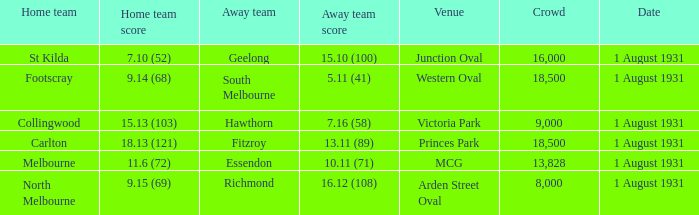Would you be able to parse every entry in this table? {'header': ['Home team', 'Home team score', 'Away team', 'Away team score', 'Venue', 'Crowd', 'Date'], 'rows': [['St Kilda', '7.10 (52)', 'Geelong', '15.10 (100)', 'Junction Oval', '16,000', '1 August 1931'], ['Footscray', '9.14 (68)', 'South Melbourne', '5.11 (41)', 'Western Oval', '18,500', '1 August 1931'], ['Collingwood', '15.13 (103)', 'Hawthorn', '7.16 (58)', 'Victoria Park', '9,000', '1 August 1931'], ['Carlton', '18.13 (121)', 'Fitzroy', '13.11 (89)', 'Princes Park', '18,500', '1 August 1931'], ['Melbourne', '11.6 (72)', 'Essendon', '10.11 (71)', 'MCG', '13,828', '1 August 1931'], ['North Melbourne', '9.15 (69)', 'Richmond', '16.12 (108)', 'Arden Street Oval', '8,000', '1 August 1931']]} What is the home team at the venue mcg? Melbourne. 